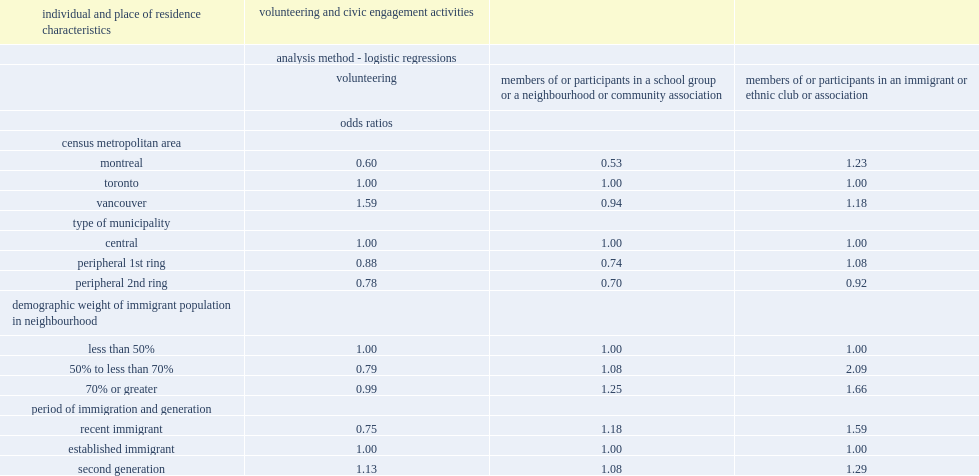In which types of neighbourhoods are the residents more likely to be part of an immigrant or ethnic organization, neighbourhoods where the demographic weight with an immigrant background is 50% to 70% or neighbourhoods where the demographic weight with an immigrant background is less than 50%? 50% to less than 70%. Which census metropolitan area has a higher propensity to volunteer, vancouver or toronto? Vancouver. In which cma are the residents less likely to volunteer, montreal or toronto? Montreal. In which cma are the residents less likely to participate in a community or neighbourhood organization, montreal or toronto? Montreal. 